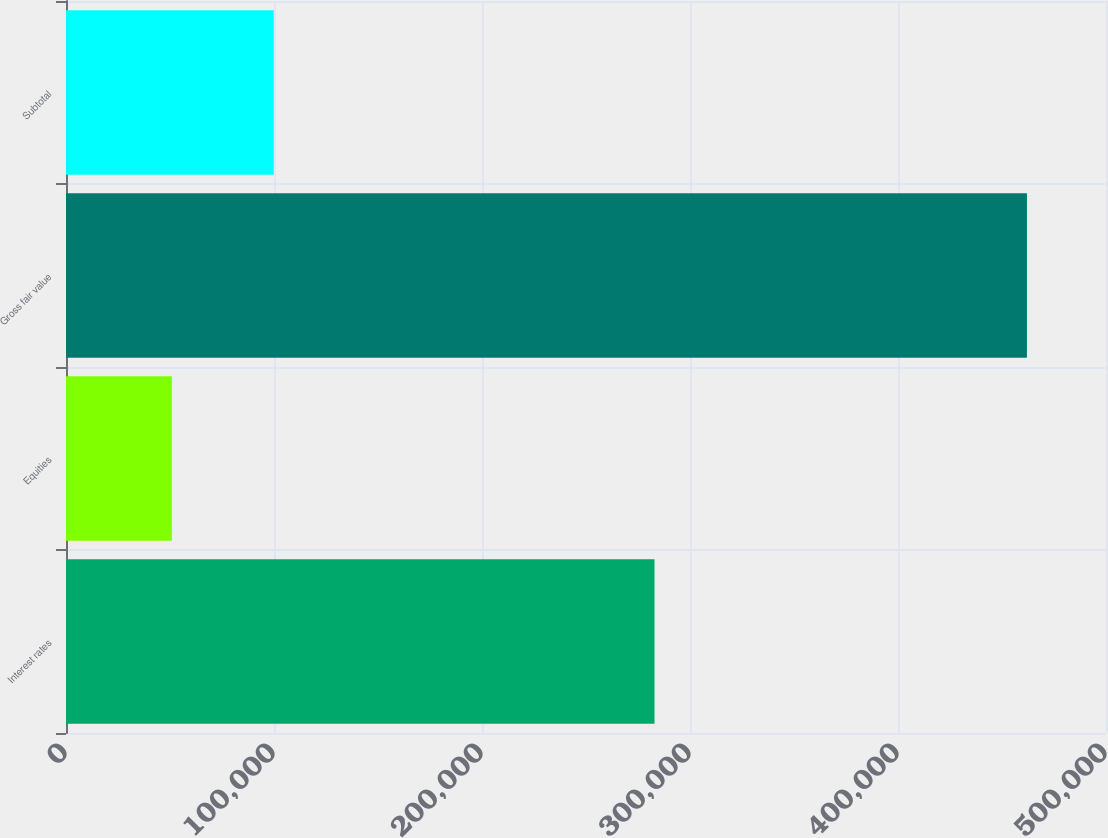<chart> <loc_0><loc_0><loc_500><loc_500><bar_chart><fcel>Interest rates<fcel>Equities<fcel>Gross fair value<fcel>Subtotal<nl><fcel>282933<fcel>50870<fcel>461984<fcel>99875<nl></chart> 